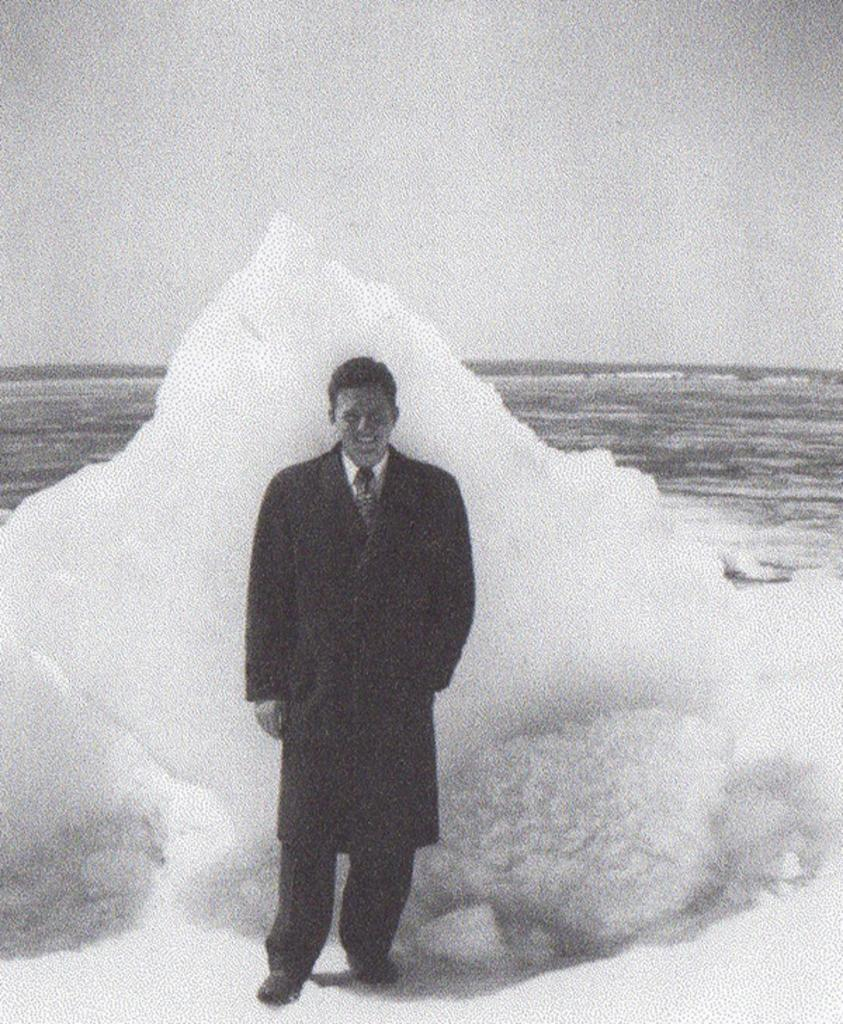What is the color scheme of the image? The image is black and white. What is the man in the image standing on? The man is standing on the ice. What is located behind the man in the image? There is an iceberg behind the man. What can be seen in the background of the image besides the iceberg? The background of the image includes sky and water. What type of coal is being mined by the man in the image? There is no coal or mining activity depicted in the image; it features a man standing on ice with an iceberg in the background. 